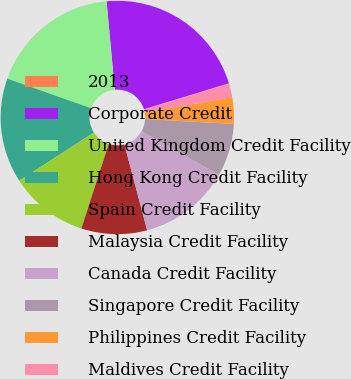Convert chart. <chart><loc_0><loc_0><loc_500><loc_500><pie_chart><fcel>2013<fcel>Corporate Credit<fcel>United Kingdom Credit Facility<fcel>Hong Kong Credit Facility<fcel>Spain Credit Facility<fcel>Malaysia Credit Facility<fcel>Canada Credit Facility<fcel>Singapore Credit Facility<fcel>Philippines Credit Facility<fcel>Maldives Credit Facility<nl><fcel>0.07%<fcel>21.74%<fcel>18.13%<fcel>14.51%<fcel>10.9%<fcel>9.1%<fcel>12.71%<fcel>7.29%<fcel>3.68%<fcel>1.87%<nl></chart> 